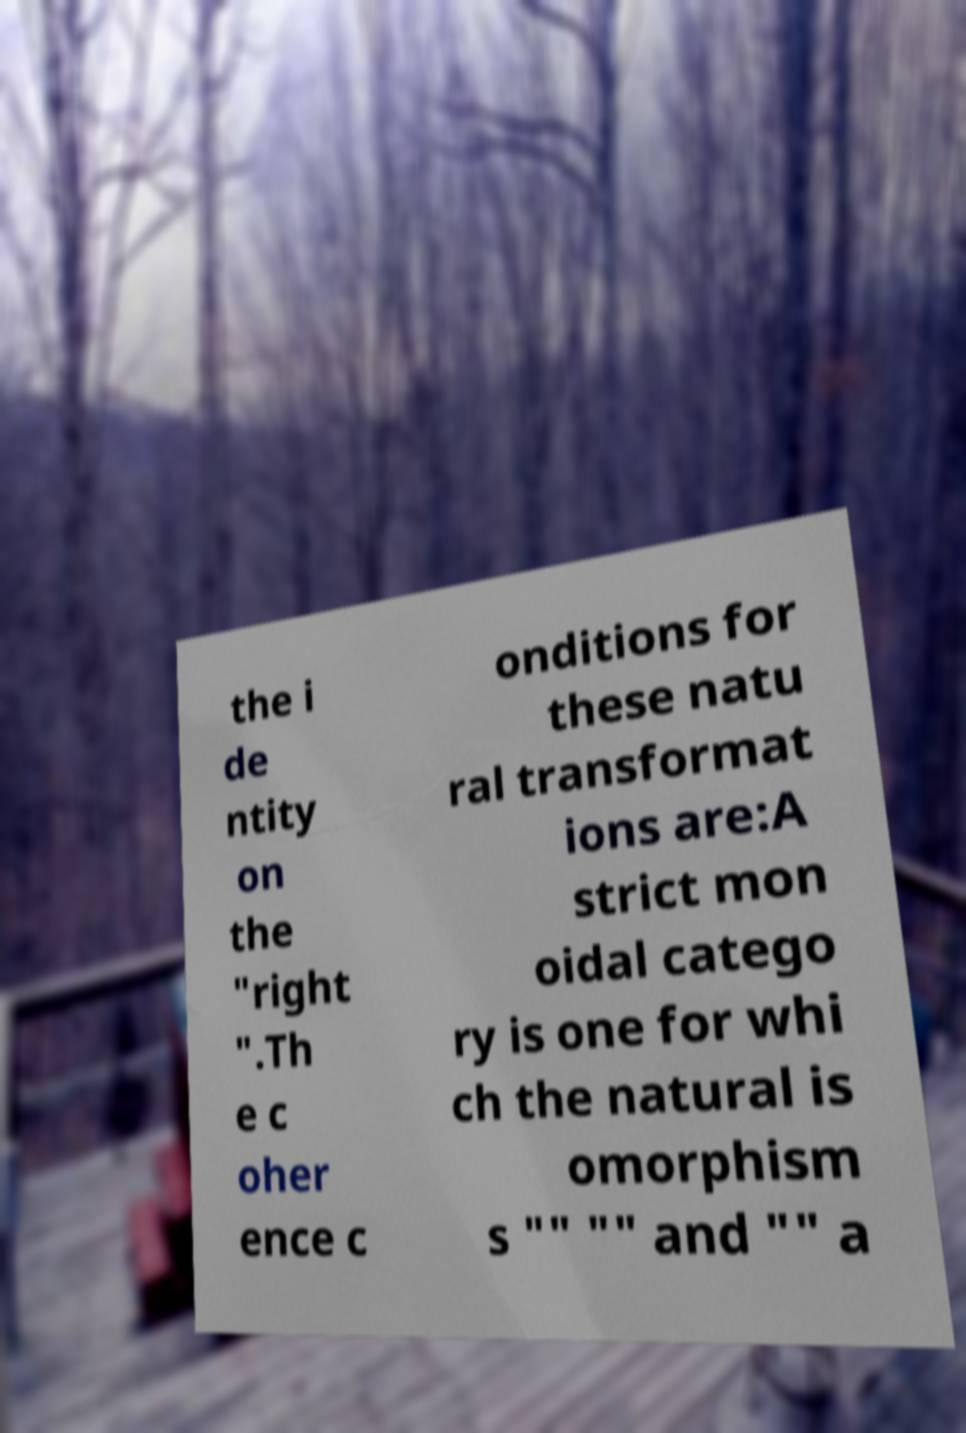I need the written content from this picture converted into text. Can you do that? the i de ntity on the "right ".Th e c oher ence c onditions for these natu ral transformat ions are:A strict mon oidal catego ry is one for whi ch the natural is omorphism s "" "" and "" a 